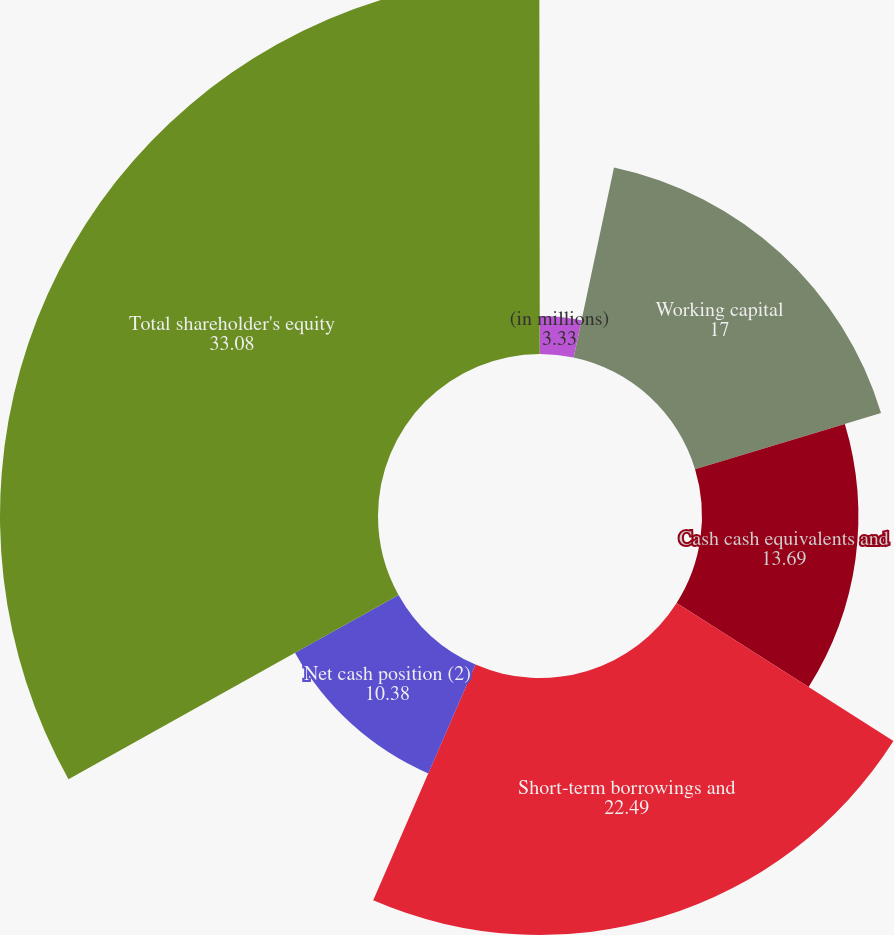Convert chart to OTSL. <chart><loc_0><loc_0><loc_500><loc_500><pie_chart><fcel>(in millions)<fcel>Working capital<fcel>Cash cash equivalents and<fcel>Short-term borrowings and<fcel>Net cash position (2)<fcel>Total shareholder's equity<fcel>Debt-to-total capital ratio<nl><fcel>3.33%<fcel>17.0%<fcel>13.69%<fcel>22.49%<fcel>10.38%<fcel>33.08%<fcel>0.02%<nl></chart> 